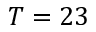Convert formula to latex. <formula><loc_0><loc_0><loc_500><loc_500>T = 2 3</formula> 